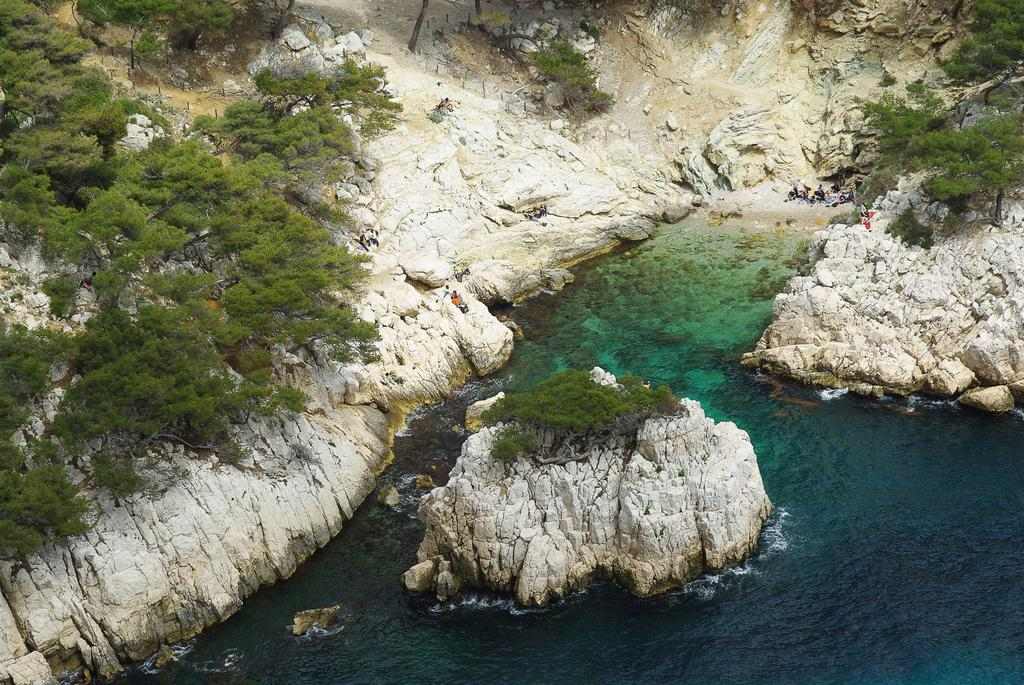What type of vegetation can be seen in the image? There are trees in the image. What geographical feature is present in the image? There is a hill in the image. What type of terrain can be seen in the image? There is thicket in the image. What natural element is visible in the image? There is water visible in the image. What type of solid material is present in the image? There are rocks in the image. How many houses are visible in the image? There are no houses present in the image. What type of clothing is hanging on the trees in the image? There is no clothing, such as a stocking, hanging on the trees in the image. 